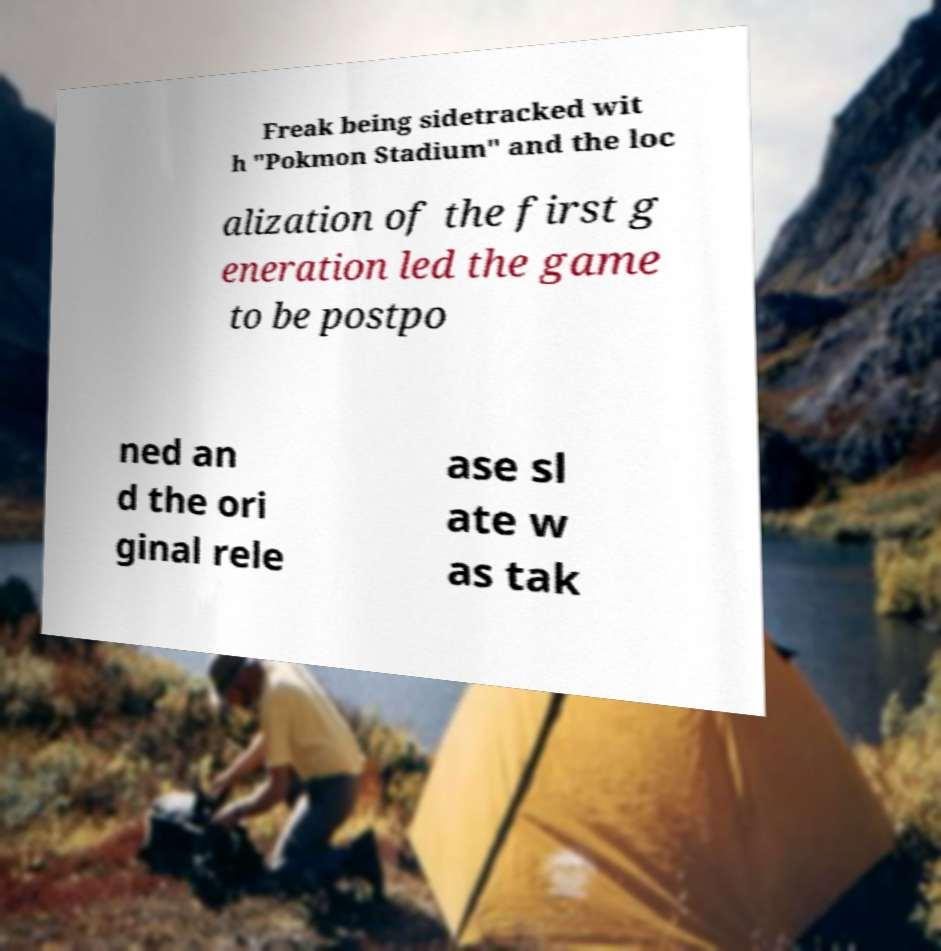Could you assist in decoding the text presented in this image and type it out clearly? Freak being sidetracked wit h "Pokmon Stadium" and the loc alization of the first g eneration led the game to be postpo ned an d the ori ginal rele ase sl ate w as tak 